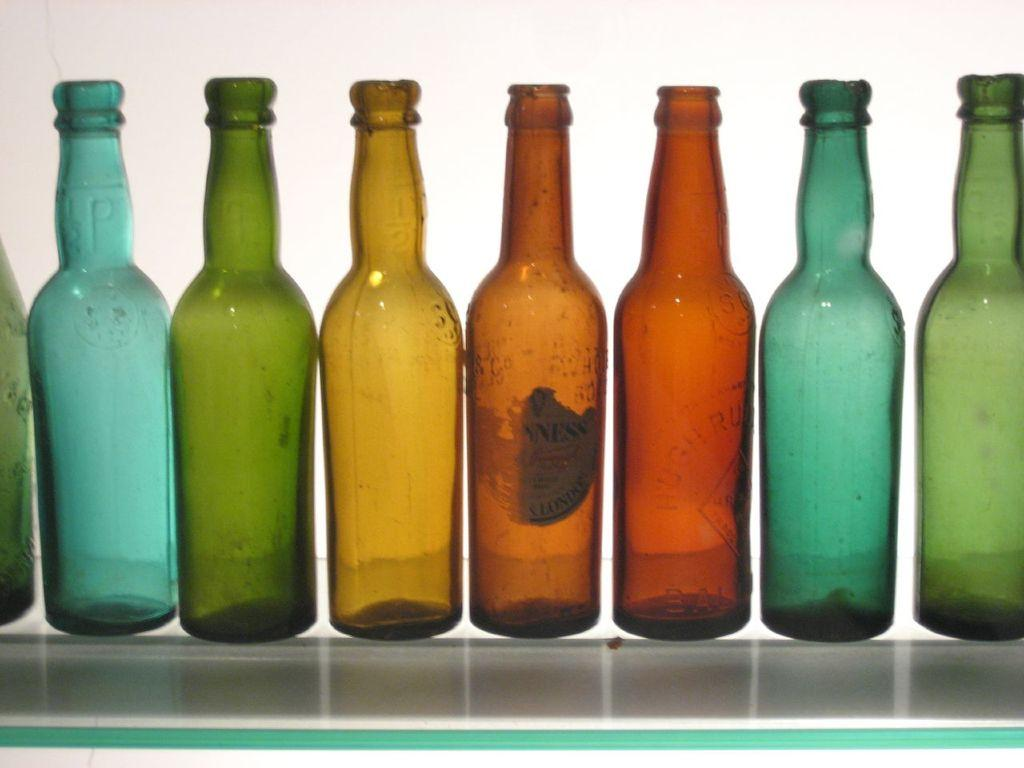How many bottles are present in the image? There are eight bottles in the image. What distinguishes the bottles from one another? Each of the bottles has a different color. What type of whip is being used to maintain peace among the bottles in the image? There is no whip or any indication of force in the image; the bottles are simply displayed with different colors. 